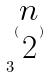Convert formula to latex. <formula><loc_0><loc_0><loc_500><loc_500>3 ^ { ( \begin{matrix} n \\ 2 \end{matrix} ) }</formula> 